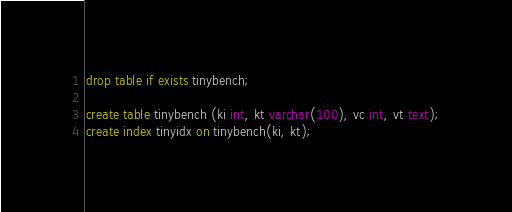Convert code to text. <code><loc_0><loc_0><loc_500><loc_500><_SQL_>drop table if exists tinybench;

create table tinybench (ki int, kt varchar(100), vc int, vt text);
create index tinyidx on tinybench(ki, kt);

</code> 